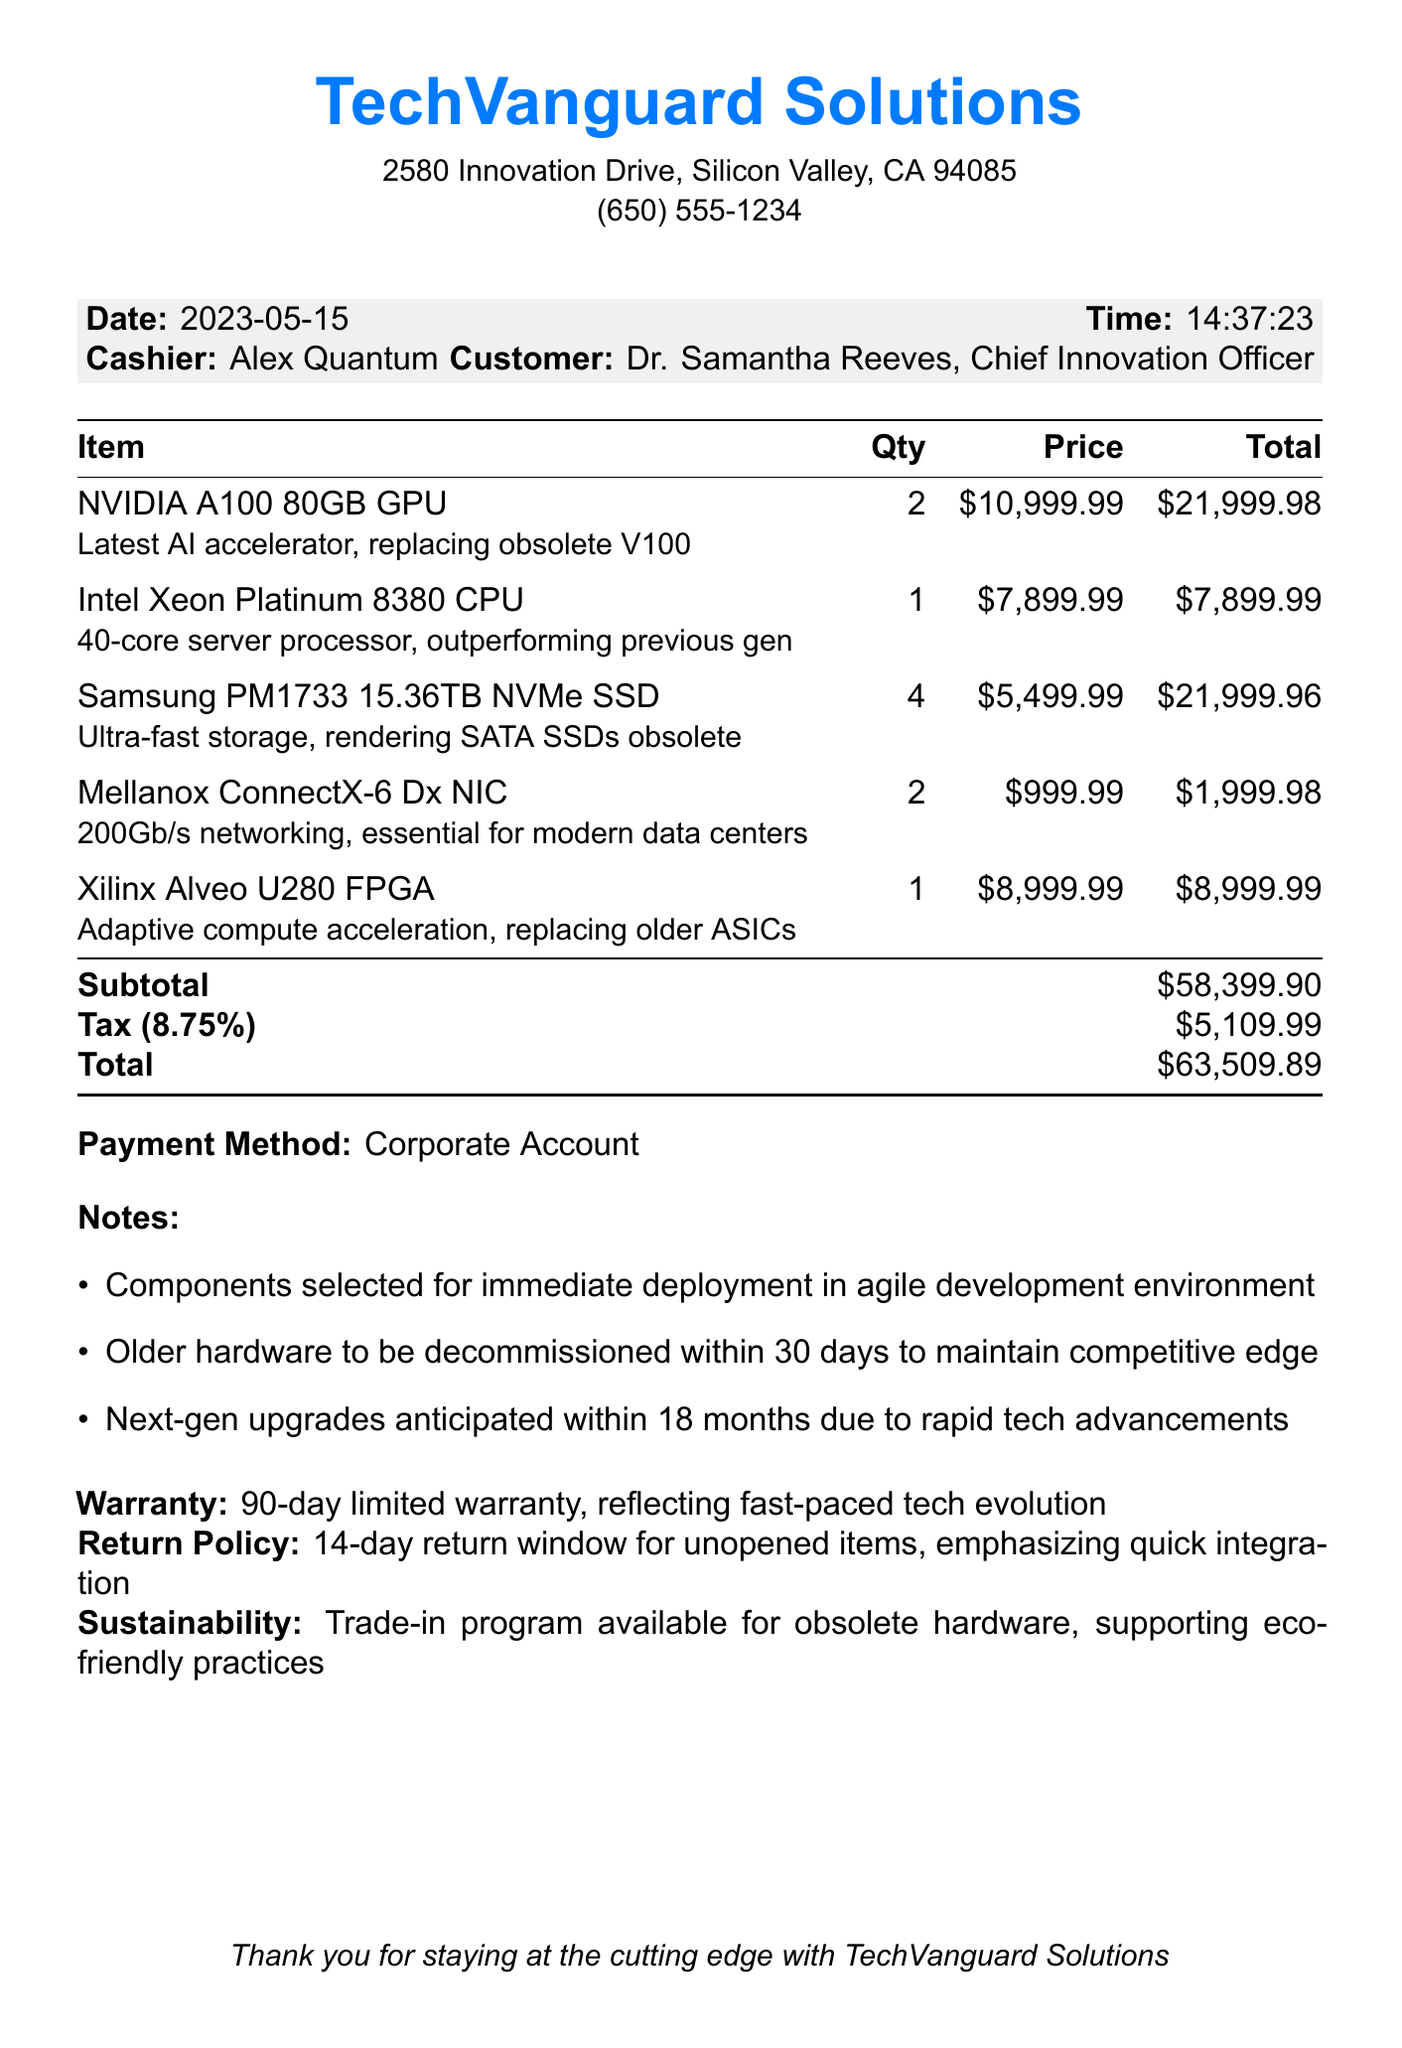what is the store name? The store name is prominently shown at the top of the receipt.
Answer: TechVanguard Solutions who is the customer? The customer's name is listed under the cashier's name.
Answer: Dr. Samantha Reeves, Chief Innovation Officer what is the total amount of the purchase? The total amount is calculated at the end of the receipt.
Answer: $63,509.89 how many Samsung PM1733 15.36TB NVMe SSDs were purchased? The quantity of this specific item is detailed in the itemized list.
Answer: 4 what is the warranty period for the purchased items? The warranty section mentions the duration after the total.
Answer: 90-day limited warranty why are older hardware components being decommissioned? The notes section states the reasoning behind the decision.
Answer: To maintain competitive edge when were the components bought? The date of purchase is specified near the top of the document.
Answer: 2023-05-15 what is the return policy for the purchased items? The return policy is explicitly mentioned for unopened items.
Answer: 14-day return window for unopened items how many NVIDIA A100 80GB GPUs were bought? The quantity can be found in the items list.
Answer: 2 what is the tax amount on the purchase? The tax amount is calculated and shown in the total section.
Answer: $5,109.99 